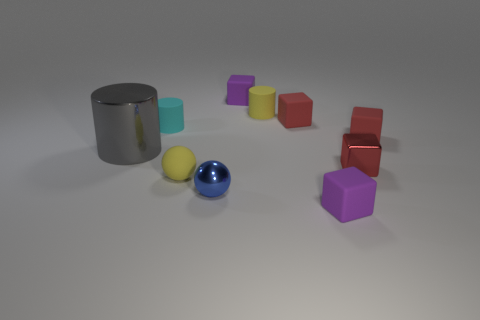Subtract all small purple cubes. How many cubes are left? 3 Subtract all purple blocks. How many blocks are left? 3 Subtract 2 spheres. How many spheres are left? 0 Subtract all purple cubes. Subtract all brown balls. How many cubes are left? 3 Add 8 small yellow objects. How many small yellow objects exist? 10 Subtract 1 gray cylinders. How many objects are left? 9 Subtract all spheres. How many objects are left? 8 Subtract all blue balls. How many red cylinders are left? 0 Subtract all small blue cylinders. Subtract all small purple blocks. How many objects are left? 8 Add 9 blue objects. How many blue objects are left? 10 